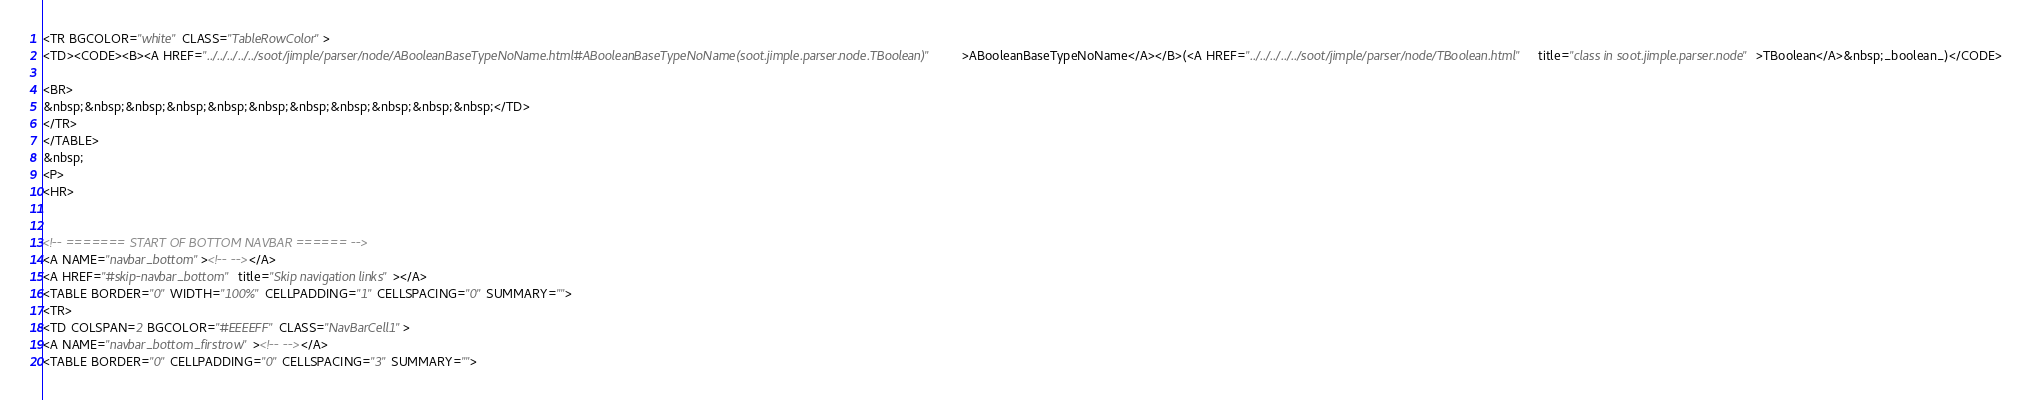Convert code to text. <code><loc_0><loc_0><loc_500><loc_500><_HTML_><TR BGCOLOR="white" CLASS="TableRowColor">
<TD><CODE><B><A HREF="../../../../../soot/jimple/parser/node/ABooleanBaseTypeNoName.html#ABooleanBaseTypeNoName(soot.jimple.parser.node.TBoolean)">ABooleanBaseTypeNoName</A></B>(<A HREF="../../../../../soot/jimple/parser/node/TBoolean.html" title="class in soot.jimple.parser.node">TBoolean</A>&nbsp;_boolean_)</CODE>

<BR>
&nbsp;&nbsp;&nbsp;&nbsp;&nbsp;&nbsp;&nbsp;&nbsp;&nbsp;&nbsp;&nbsp;</TD>
</TR>
</TABLE>
&nbsp;
<P>
<HR>


<!-- ======= START OF BOTTOM NAVBAR ====== -->
<A NAME="navbar_bottom"><!-- --></A>
<A HREF="#skip-navbar_bottom" title="Skip navigation links"></A>
<TABLE BORDER="0" WIDTH="100%" CELLPADDING="1" CELLSPACING="0" SUMMARY="">
<TR>
<TD COLSPAN=2 BGCOLOR="#EEEEFF" CLASS="NavBarCell1">
<A NAME="navbar_bottom_firstrow"><!-- --></A>
<TABLE BORDER="0" CELLPADDING="0" CELLSPACING="3" SUMMARY=""></code> 